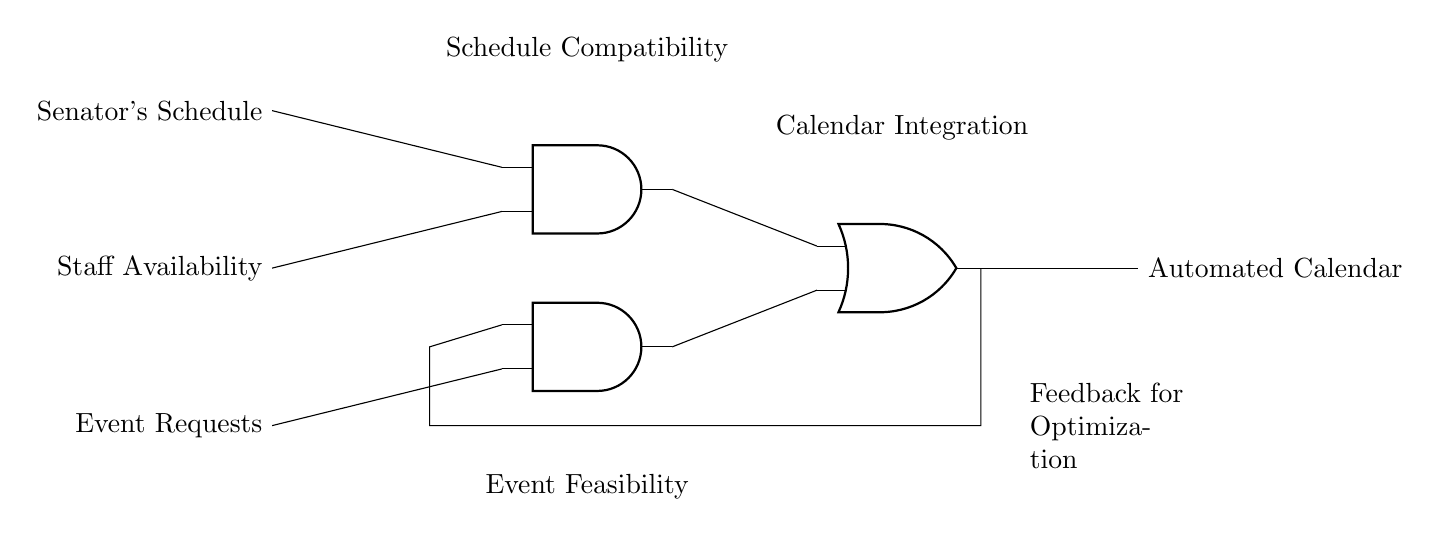What are the input signals to the AND gates? The input signals are the senator's schedule, staff availability, and event requests. The senator's schedule and staff availability are connected to the first AND gate, while the event requests are connected to the second AND gate.
Answer: senator's schedule, staff availability, event requests How many AND gates are present in this circuit? There are two AND gates in the circuit, which can be identified by the components labeled as AND ports. Each AND gate combines different inputs.
Answer: two What is the output of the OR gate? The output of the OR gate is the automated calendar, which combines outputs from both AND gates based on the defined logical functions.
Answer: automated calendar What does the feedback loop do in the circuit? The feedback loop optimizes the event feasibility input for the second AND gate by taking output from the OR gate back into the circuit. This dynamic adjustment allows better scheduling accuracy based on previous outputs.
Answer: optimization What type of gate combines the outputs from the AND gates? The gate that combines the outputs from the AND gates is an OR gate. It processes inputs from both AND gates to create a single output for the automated calendar.
Answer: OR gate What indicates the compatibility of the senator's schedule with the availability? The first AND gate indicates compatibility, as it processes the senator's schedule and staff availability, producing an output only if both inputs are positively aligned.
Answer: Schedule Compatibility Which output represents both the integration of calendars? The output from the OR gate represents the integration of the schedules, as it signifies that at least one of the conditions from the AND gates is satisfied, leading to an automated scheduling decision.
Answer: Calendar Integration 